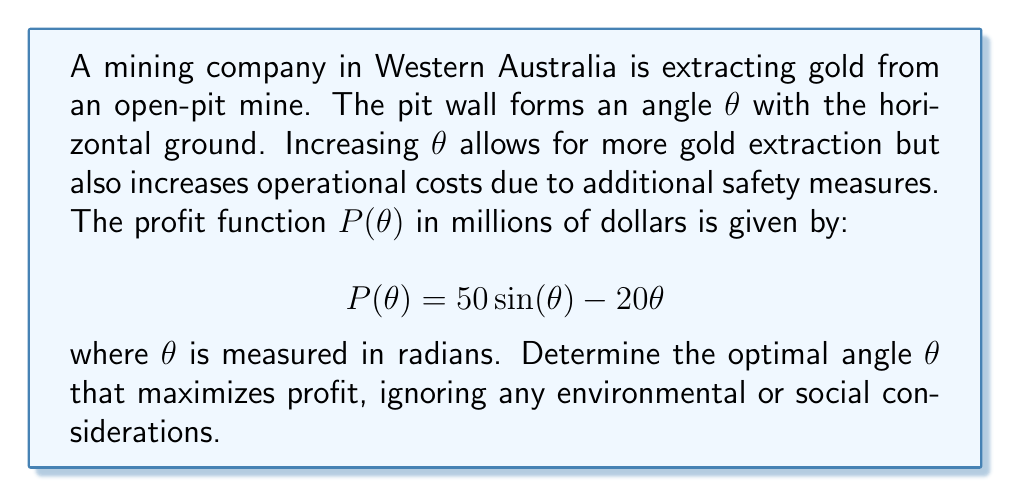Can you solve this math problem? To find the optimal angle that maximizes profit, we need to find the maximum of the function P(θ). This can be done by finding the value of θ where the derivative of P(θ) equals zero.

Step 1: Calculate the derivative of P(θ)
$$ P'(\theta) = 50\cos(\theta) - 20 $$

Step 2: Set the derivative equal to zero and solve for θ
$$ 50\cos(\theta) - 20 = 0 $$
$$ 50\cos(\theta) = 20 $$
$$ \cos(\theta) = \frac{2}{5} $$
$$ \theta = \arccos(\frac{2}{5}) $$

Step 3: Verify that this is a maximum by checking the second derivative
$$ P''(\theta) = -50\sin(\theta) $$
At θ = arccos(2/5), P''(θ) is negative, confirming a maximum.

Step 4: Calculate the numerical value of θ
$$ \theta \approx 1.369 \text{ radians} $$
$$ \theta \approx 78.46\text{°} $$

Therefore, the optimal angle for maximizing profit is approximately 1.369 radians or 78.46°.
Answer: $\theta = \arccos(\frac{2}{5}) \approx 1.369 \text{ radians} \approx 78.46\text{°}$ 